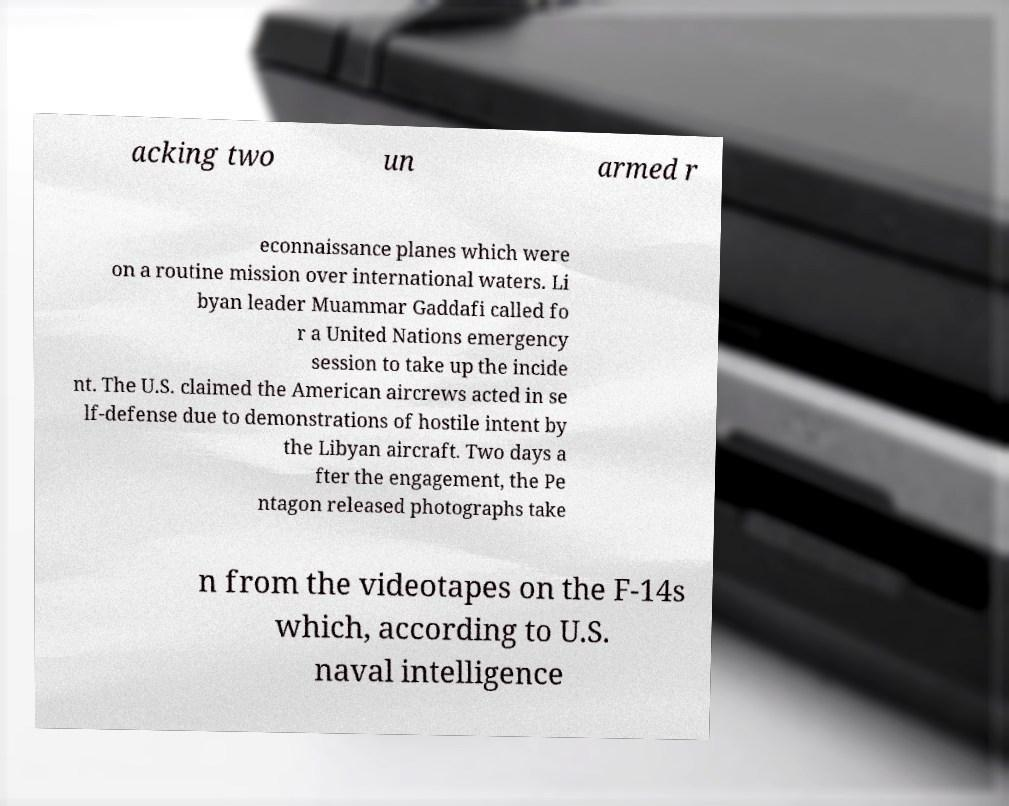There's text embedded in this image that I need extracted. Can you transcribe it verbatim? acking two un armed r econnaissance planes which were on a routine mission over international waters. Li byan leader Muammar Gaddafi called fo r a United Nations emergency session to take up the incide nt. The U.S. claimed the American aircrews acted in se lf-defense due to demonstrations of hostile intent by the Libyan aircraft. Two days a fter the engagement, the Pe ntagon released photographs take n from the videotapes on the F-14s which, according to U.S. naval intelligence 